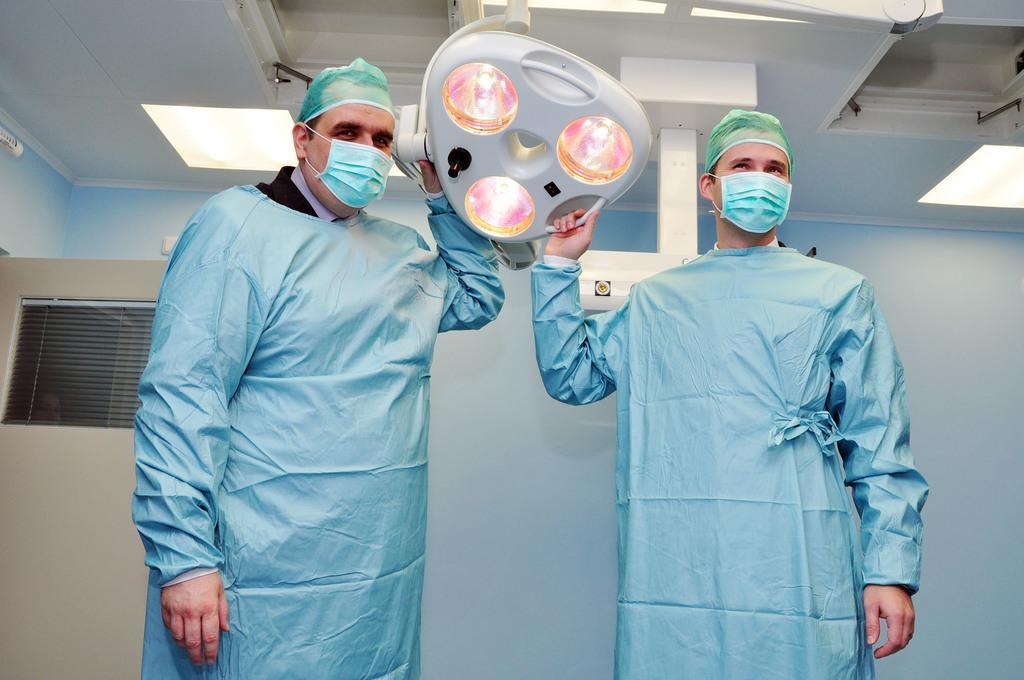Describe this image in one or two sentences. In this image I can see two men are standing and wearing blue color clothes, face masks and other objects. These men are holding some object in hands. In the background I can see a machine, a wall, lights on the ceiling and other objects. 